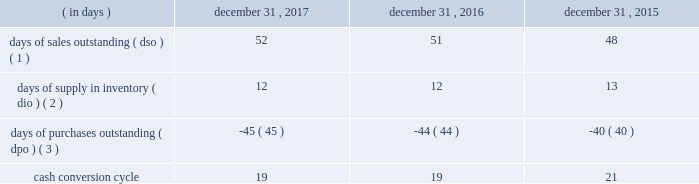Table of contents ( 4 ) the increase in cash flows was primarily due to the timing of inventory purchases and longer payment terms with certain vendors .
In order to manage our working capital and operating cash needs , we monitor our cash conversion cycle , defined as days of sales outstanding in accounts receivable plus days of supply in inventory minus days of purchases outstanding in accounts payable , based on a rolling three-month average .
Components of our cash conversion cycle are as follows: .
( 1 ) represents the rolling three-month average of the balance of accounts receivable , net at the end of the period , divided by average daily net sales for the same three-month period .
Also incorporates components of other miscellaneous receivables .
( 2 ) represents the rolling three-month average of the balance of merchandise inventory at the end of the period divided by average daily cost of sales for the same three-month period .
( 3 ) represents the rolling three-month average of the combined balance of accounts payable-trade , excluding cash overdrafts , and accounts payable-inventory financing at the end of the period divided by average daily cost of sales for the same three-month period .
The cash conversion cycle was 19 days at december 31 , 2017 and 2016 .
The increase in dso was primarily driven by higher net sales and related accounts receivable for third-party services such as saas , software assurance and warranties .
These services have an unfavorable impact on dso as the receivable is recognized on the consolidated balance sheet on a gross basis while the corresponding sales amount in the consolidated statement of operations is recorded on a net basis .
This also results in a favorable impact on dpo as the payable is recognized on the consolidated balance sheet without a corresponding cost of sales in the statement of operations because the cost paid to the vendor or third-party service provider is recorded as a reduction to net sales .
In addition , dpo also increased due to the mix of payables with certain vendors that have longer payment terms .
The cash conversion cycle was 19 and 21 days at december 31 , 2016 and 2015 , respectively .
The increase in dso was primarily driven by higher net sales and related accounts receivable for third-party services such as saas , software assurance and warranties .
These services have an unfavorable impact on dso as the receivable is recognized on the balance sheet on a gross basis while the corresponding sales amount in the statement of operations is recorded on a net basis .
These services have a favorable impact on dpo as the payable is recognized on the balance sheet without a corresponding cost of sale in the statement of operations because the cost paid to the vendor or third-party service provider is recorded as a reduction to net sales .
In addition to the impact of these services on dpo , dpo also increased due to the mix of payables with certain vendors that have longer payment terms .
Investing activities net cash used in investing activities increased $ 15 million in 2017 compared to 2016 .
Capital expenditures increased $ 17 million to $ 81 million from $ 64 million for 2017 and 2016 , respectively , primarily related to improvements to our information technology systems .
Net cash used in investing activities decreased $ 289 million in 2016 compared to 2015 .
The decrease in cash used was primarily due to the completion of the acquisition of cdw uk in 2015 .
Additionally , capital expenditures decreased $ 26 million to $ 64 million from $ 90 million for 2016 and 2015 , respectively , primarily due to spending for our new office location in 2015 .
Financing activities net cash used in financing activities increased $ 514 million in 2017 compared to 2016 .
The increase was primarily driven by changes in accounts payable-inventory financing , which resulted in an increase in cash used for financing activities of $ 228 million and by share repurchases during 2017 , which resulted in an increase in cash used for financing activities of $ 167 million .
For more information on our share repurchase program , see part ii , item 5 , 201cmarket for registrant 2019s common equity , related stockholder matters and issuer purchases of equity securities . 201d the increase in cash used for accounts payable-inventory financing was primarily driven by the termination of one of our inventory financing agreements in the fourth quarter of 2016 , with amounts .
What was the average capital expenditures , in millions , for 2016 and 2015? 
Computations: ((90 + 64) / 2)
Answer: 77.0. 